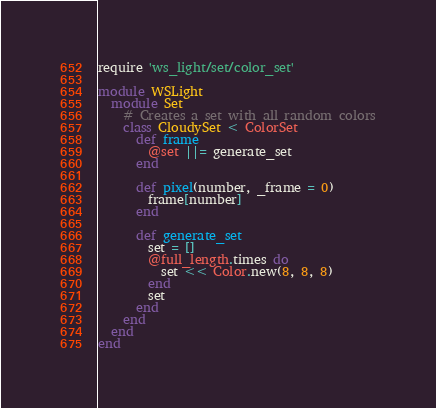<code> <loc_0><loc_0><loc_500><loc_500><_Ruby_>require 'ws_light/set/color_set'

module WSLight
  module Set
    # Creates a set with all random colors
    class CloudySet < ColorSet
      def frame
        @set ||= generate_set
      end

      def pixel(number, _frame = 0)
        frame[number]
      end

      def generate_set
        set = []
        @full_length.times do
          set << Color.new(8, 8, 8)
        end
        set
      end
    end
  end
end
</code> 